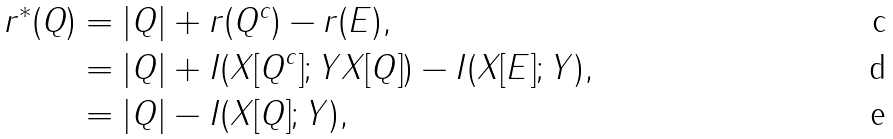<formula> <loc_0><loc_0><loc_500><loc_500>r ^ { * } ( Q ) & = | Q | + r ( Q ^ { c } ) - r ( E ) , \\ & = | Q | + I ( X [ Q ^ { c } ] ; Y X [ Q ] ) - I ( X [ E ] ; Y ) , \\ & = | Q | - I ( X [ Q ] ; Y ) ,</formula> 